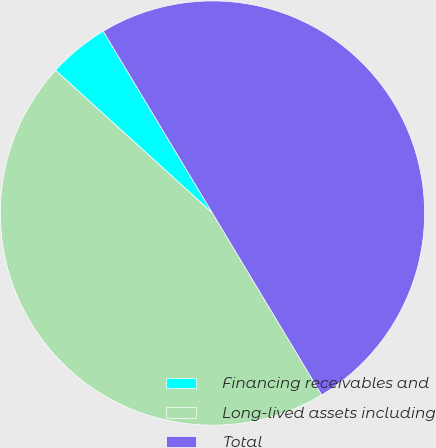Convert chart. <chart><loc_0><loc_0><loc_500><loc_500><pie_chart><fcel>Financing receivables and<fcel>Long-lived assets including<fcel>Total<nl><fcel>4.65%<fcel>45.35%<fcel>50.0%<nl></chart> 